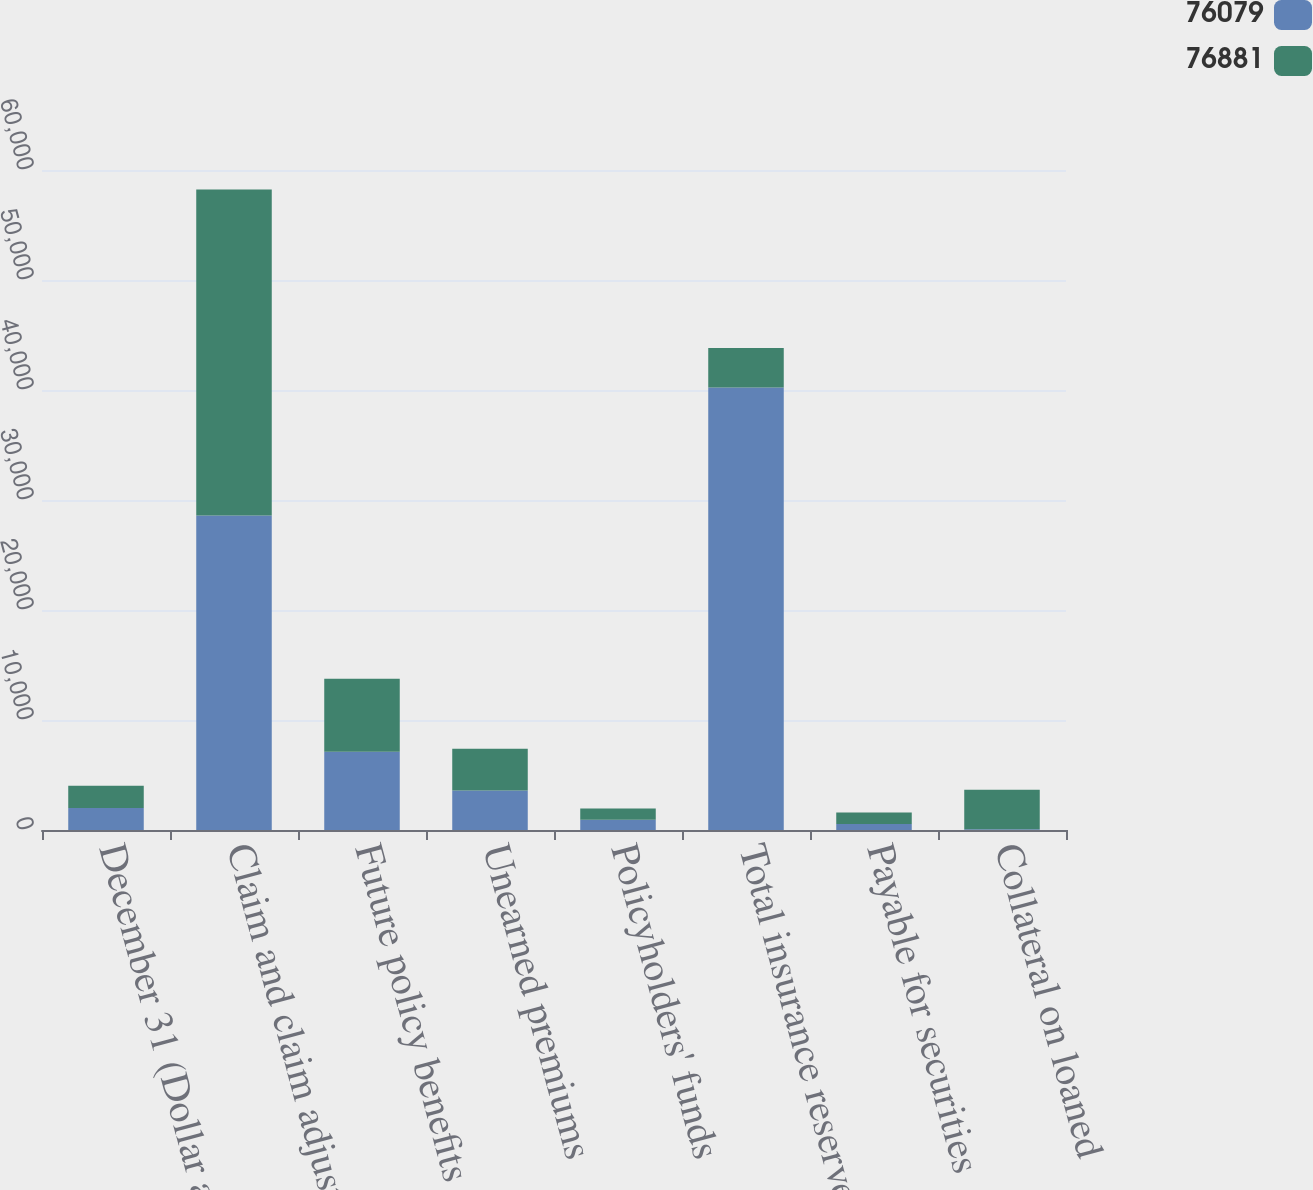Convert chart. <chart><loc_0><loc_0><loc_500><loc_500><stacked_bar_chart><ecel><fcel>December 31 (Dollar amounts in<fcel>Claim and claim adjustment<fcel>Future policy benefits<fcel>Unearned premiums<fcel>Policyholders' funds<fcel>Total insurance reserves<fcel>Payable for securities<fcel>Collateral on loaned<nl><fcel>76079<fcel>2007<fcel>28588<fcel>7106<fcel>3597<fcel>930<fcel>40221<fcel>544<fcel>63<nl><fcel>76881<fcel>2006<fcel>29636<fcel>6645<fcel>3784<fcel>1015<fcel>3597<fcel>1047<fcel>3602<nl></chart> 